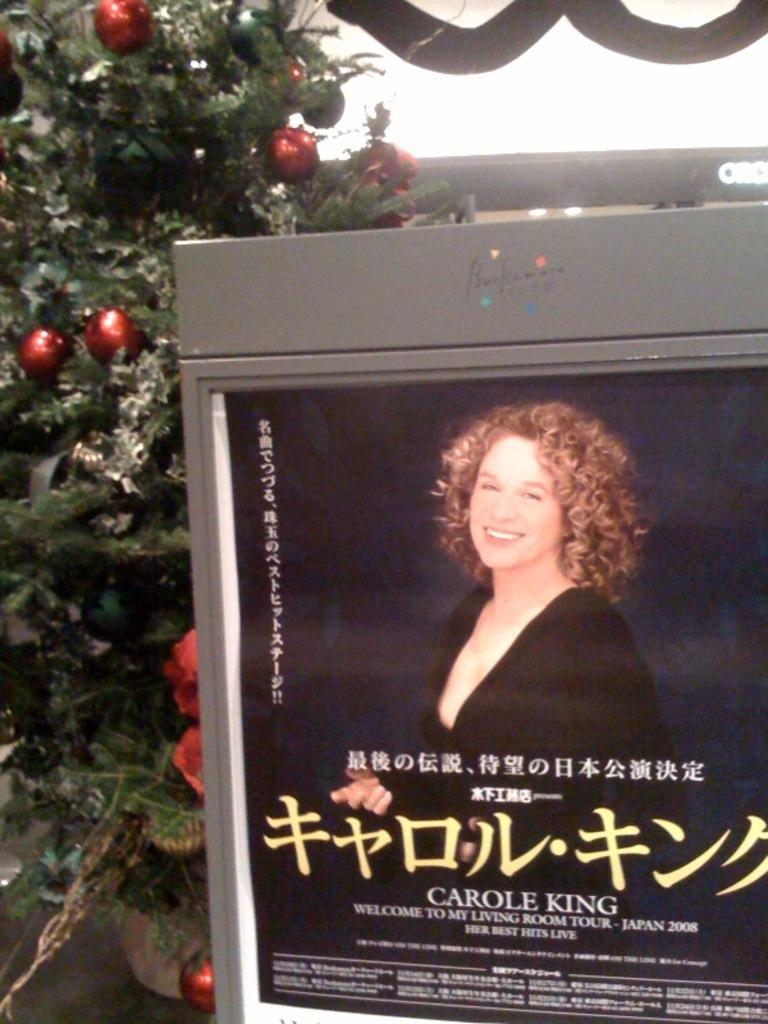What is the main object in the image? There is a digital display board in the image. What is featured on the digital display board? The digital display board includes an image of a person and text. What else can be seen in the image besides the digital display board? There is a tree in the image. What type of button is being pushed by the person on the digital display board? There is no button being pushed by the person on the digital display board; it is an image on the screen. What kind of drug is being advertised on the digital display board? There is no drug being advertised on the digital display board; the text and image are not related to any drug. 